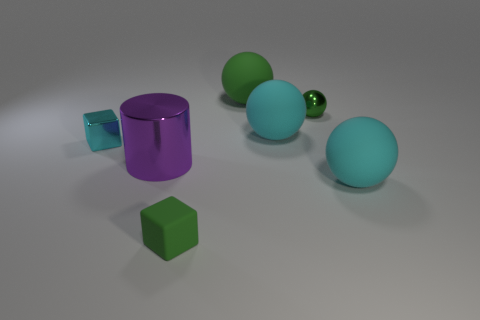There is a tiny object that is in front of the rubber sphere that is in front of the purple thing in front of the big green rubber sphere; what shape is it?
Offer a very short reply. Cube. Does the cyan ball in front of the small cyan metallic cube have the same size as the metallic thing to the left of the large shiny thing?
Your answer should be compact. No. What number of big cylinders are the same material as the large purple thing?
Provide a succinct answer. 0. There is a tiny green metal thing that is behind the cyan thing that is in front of the tiny cyan cube; what number of tiny green metal balls are to the left of it?
Give a very brief answer. 0. Is the purple metallic object the same shape as the tiny matte object?
Your answer should be compact. No. Are there any other cyan metallic objects that have the same shape as the tiny cyan object?
Your response must be concise. No. There is a green rubber object that is the same size as the purple thing; what shape is it?
Offer a terse response. Sphere. What material is the small green thing that is on the left side of the large cyan object that is on the left side of the green sphere that is on the right side of the green rubber ball?
Keep it short and to the point. Rubber. Is the size of the rubber block the same as the cyan block?
Give a very brief answer. Yes. What material is the purple thing?
Provide a short and direct response. Metal. 